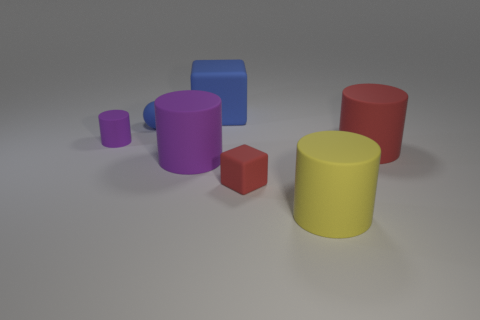What is the shape of the rubber thing that is the same color as the tiny matte cylinder?
Give a very brief answer. Cylinder. Is there anything else that is the same color as the small cylinder?
Make the answer very short. Yes. How big is the blue sphere?
Make the answer very short. Small. Are there any big purple things that have the same shape as the big red thing?
Your answer should be very brief. Yes. What number of objects are small purple metallic cylinders or matte things that are right of the tiny purple rubber cylinder?
Offer a very short reply. 6. There is a small rubber object right of the big blue matte object; what is its color?
Offer a terse response. Red. There is a rubber block behind the small cylinder; does it have the same size as the purple cylinder that is on the right side of the blue rubber sphere?
Your answer should be very brief. Yes. Are there any matte spheres of the same size as the yellow object?
Provide a succinct answer. No. How many tiny red matte blocks are in front of the purple rubber cylinder that is to the left of the small blue matte object?
Ensure brevity in your answer.  1. What is the material of the big purple cylinder?
Keep it short and to the point. Rubber. 